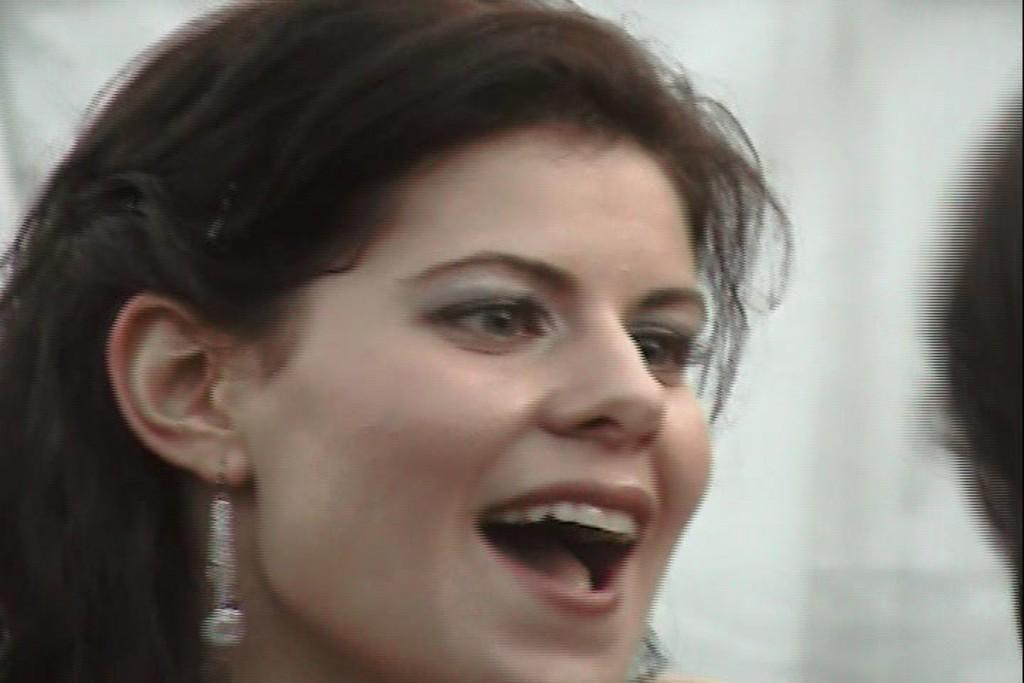Who is present in the image? There is a woman in the image. What is the woman's facial expression? The woman is smiling. What direction is the woman looking in? The woman is looking at the right side of the image. What can be seen on the right side of the image? There is a person's head on the right side of the image. How would you describe the background of the image? The background of the image is blurred. What time does the clock in the image show? There is no clock present in the image. How does the woman show respect to the person on the right side of the image? The image does not show any indication of respect being shown. Is the woman under attack in the image? There is no indication of an attack in the image. 